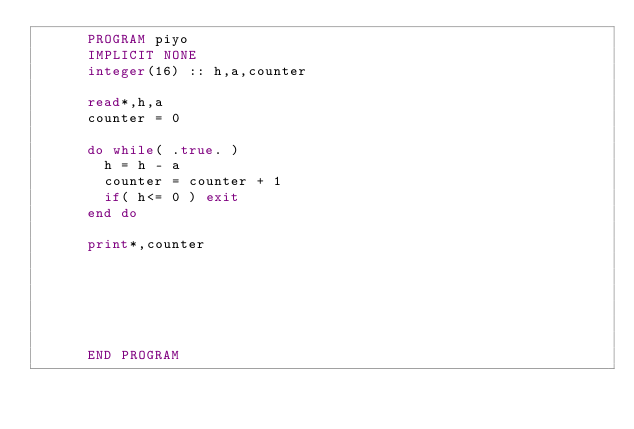Convert code to text. <code><loc_0><loc_0><loc_500><loc_500><_FORTRAN_>      PROGRAM piyo
      IMPLICIT NONE
      integer(16) :: h,a,counter
      
      read*,h,a
      counter = 0
      
      do while( .true. )
        h = h - a
        counter = counter + 1
        if( h<= 0 ) exit
      end do
      
      print*,counter
      
      
      
      
      
      
      END PROGRAM</code> 